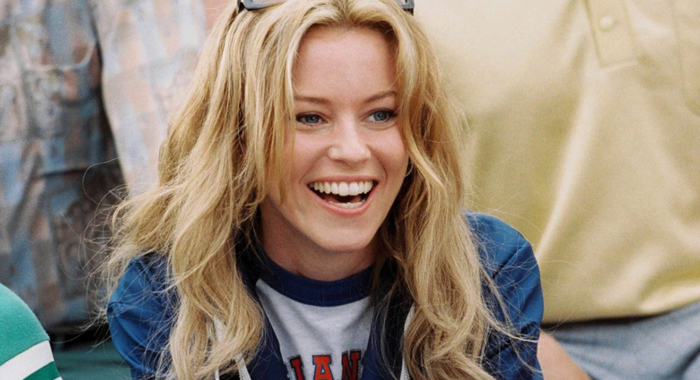Can you describe the setting or occasion where this picture might have been taken? This picture seems to be taken in a casual outdoor setting, given the natural light and the informal attire of the woman. It could be a sports event or a casual gathering where she is displaying her enthusiasm and happiness, possibly during a fun and informal event. 